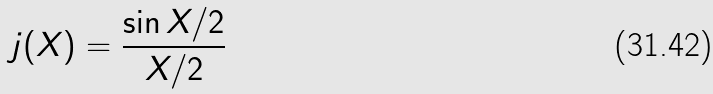Convert formula to latex. <formula><loc_0><loc_0><loc_500><loc_500>j ( X ) = \frac { \sin X / 2 } { X / 2 }</formula> 